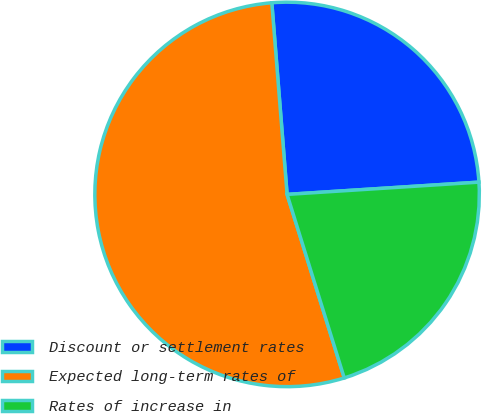Convert chart. <chart><loc_0><loc_0><loc_500><loc_500><pie_chart><fcel>Discount or settlement rates<fcel>Expected long-term rates of<fcel>Rates of increase in<nl><fcel>25.25%<fcel>53.54%<fcel>21.21%<nl></chart> 